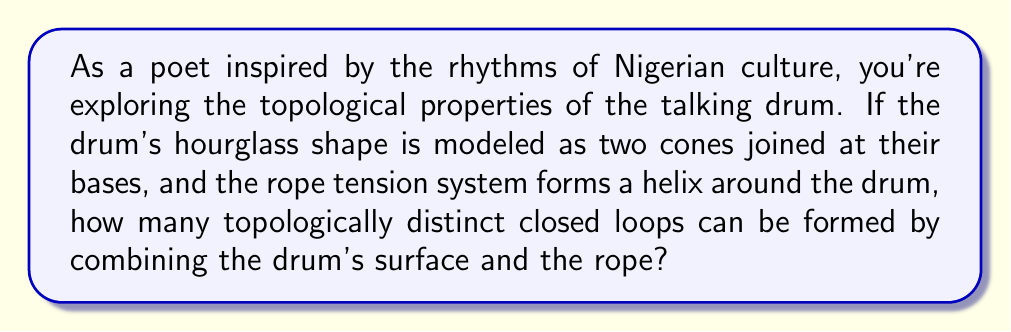Solve this math problem. To approach this problem, let's break it down into steps:

1) First, we need to understand the topology of the talking drum:
   - The drum's body is essentially two cones joined at their bases, forming an hourglass shape.
   - Topologically, this is equivalent to a cylinder, which is homeomorphic to an annulus.

2) The rope forms a helix around the drum. Topologically, a helix on a cylinder is equivalent to a diagonal line on an unwrapped cylinder (rectangle).

3) Now, we need to consider the possible closed loops:
   a) The loop around the circumference of the drum (perpendicular to its axis)
   b) The loop along the length of the drum (parallel to its axis)
   c) The loop formed by the rope itself

4) The key topological concept here is homotopy. Two loops are topologically distinct if they cannot be continuously deformed into each other without cutting.

5) Let's analyze each loop:
   - Loop (a) cannot be deformed into (b) or (c) without cutting.
   - Loop (b) can be deformed into (c) by sliding it along the surface to align with the rope's path.

6) Therefore, we have two topologically distinct closed loops:
   - One representing the circumference of the drum
   - One representing either the length of the drum or the rope (as these are homotopic)

This analysis considers the drum's surface and the rope as a single topological space. If we were to consider them separately, we would have three distinct loops, but the question asks for the combined system.
Answer: There are 2 topologically distinct closed loops in the combined system of the talking drum's surface and its tensioning rope. 